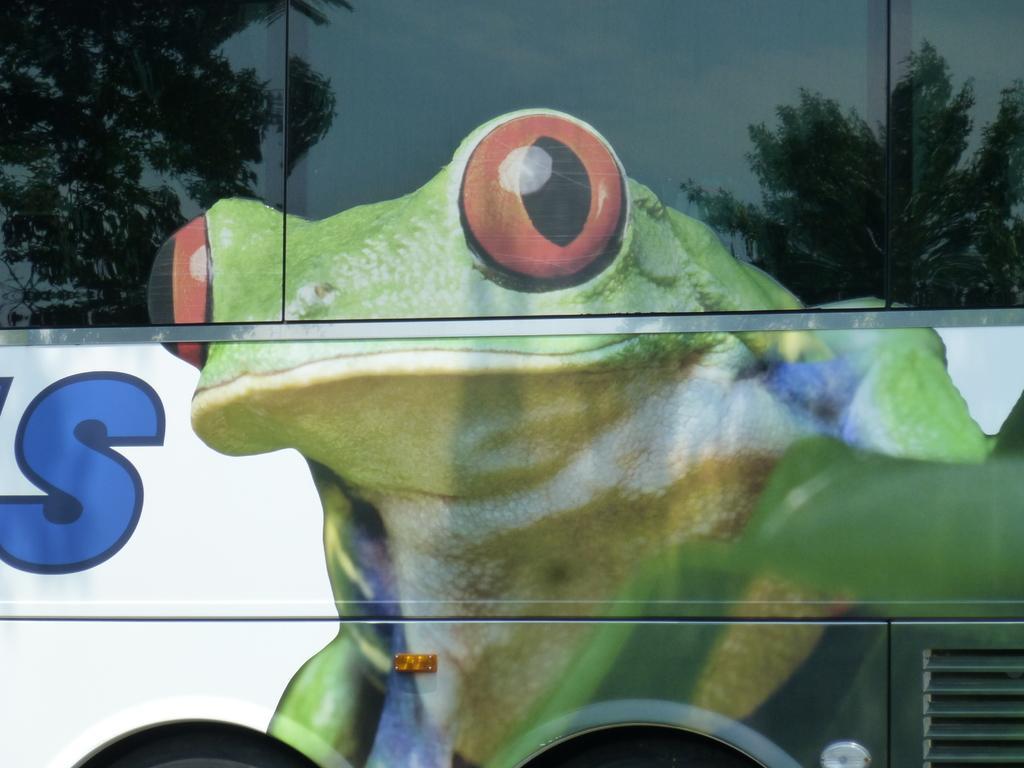Describe this image in one or two sentences. It is a zoomed in picture of a vehicle and we can see the picture of a frog. We can also see the trees and also the sky through reflection. 